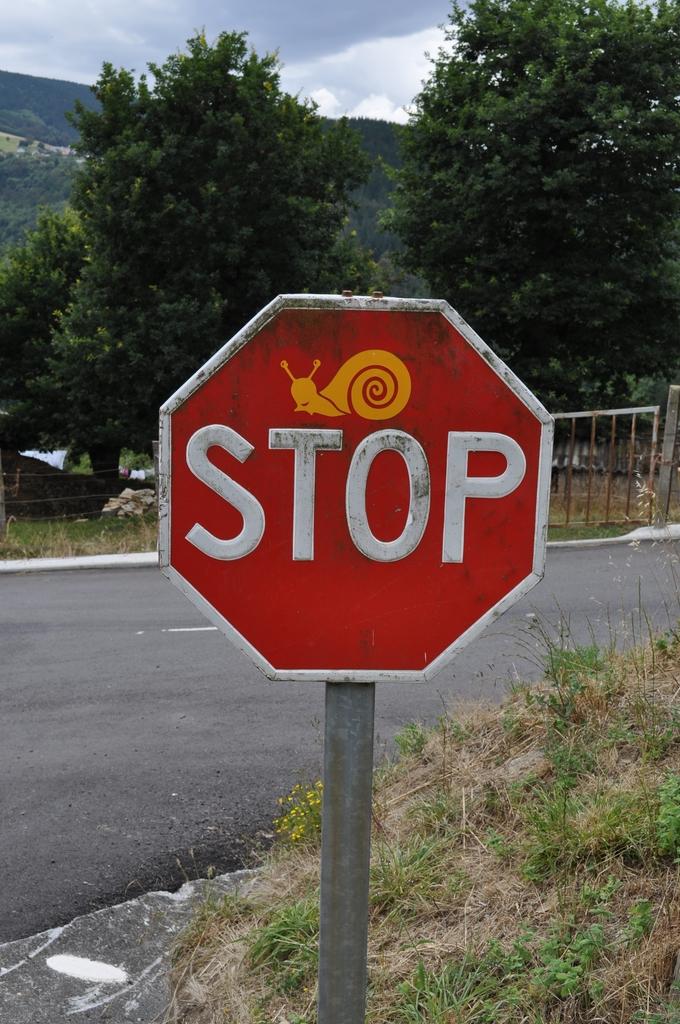What kind of sign is this?
Ensure brevity in your answer.  Stop. 